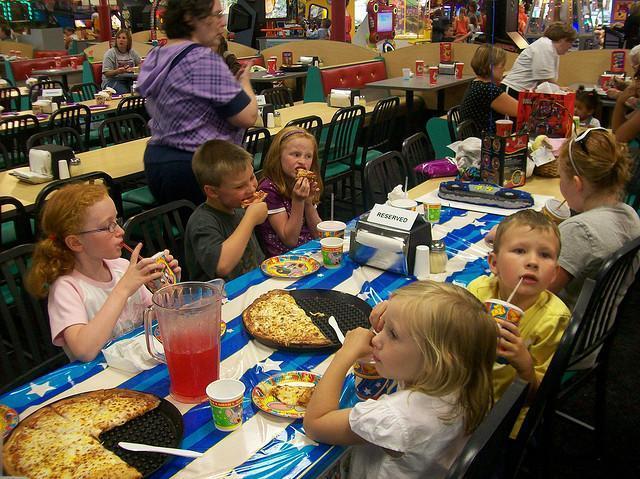How many slices of pizza are left on the pizza to the far left?
Give a very brief answer. 6. How many kids are on the photo?
Give a very brief answer. 6. How many dining tables are in the picture?
Give a very brief answer. 2. How many chairs are there?
Give a very brief answer. 6. How many people are in the photo?
Give a very brief answer. 10. 